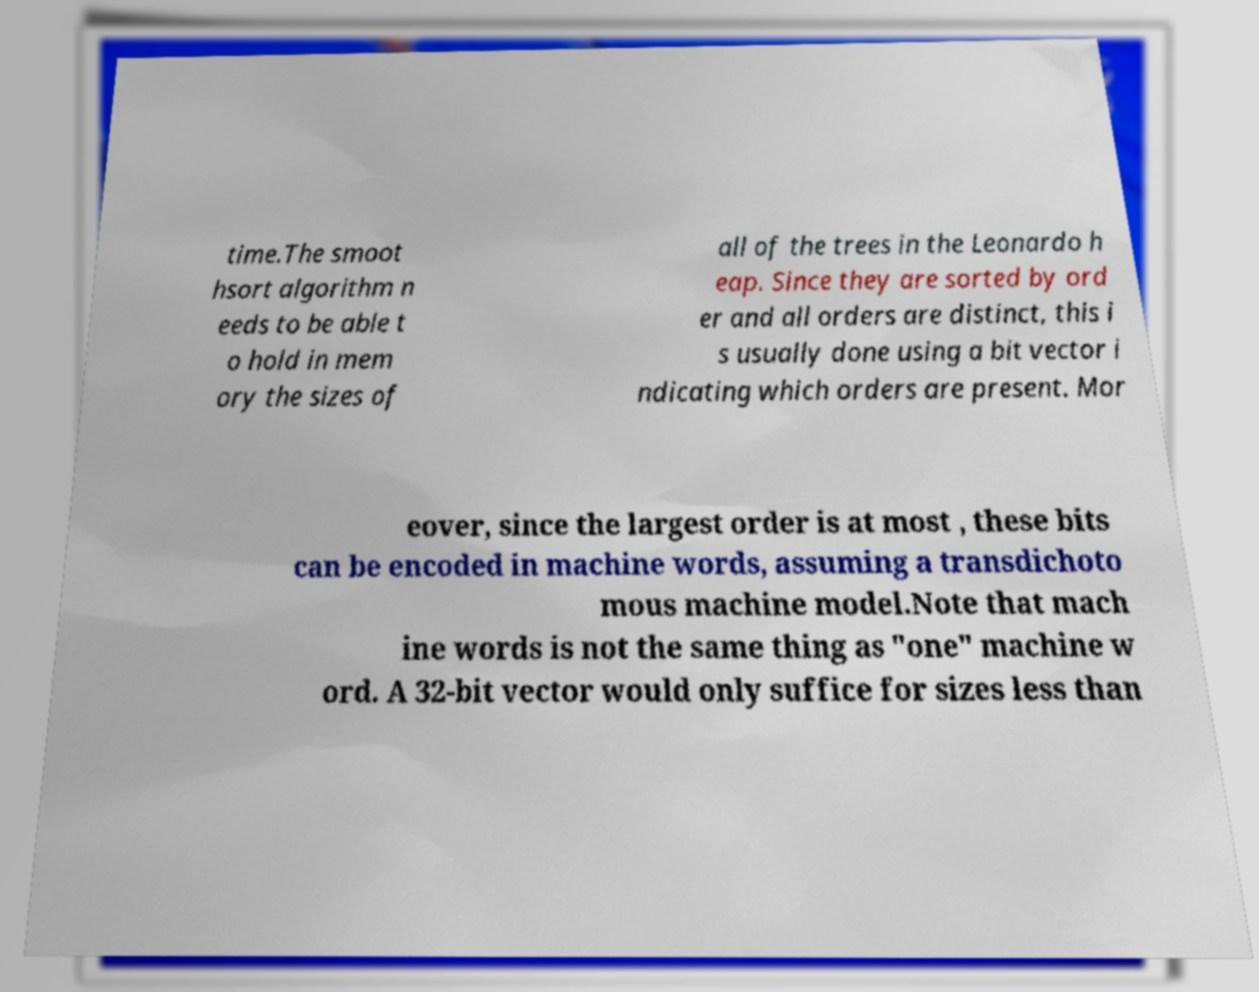For documentation purposes, I need the text within this image transcribed. Could you provide that? time.The smoot hsort algorithm n eeds to be able t o hold in mem ory the sizes of all of the trees in the Leonardo h eap. Since they are sorted by ord er and all orders are distinct, this i s usually done using a bit vector i ndicating which orders are present. Mor eover, since the largest order is at most , these bits can be encoded in machine words, assuming a transdichoto mous machine model.Note that mach ine words is not the same thing as "one" machine w ord. A 32-bit vector would only suffice for sizes less than 